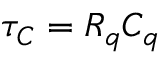<formula> <loc_0><loc_0><loc_500><loc_500>\tau _ { C } = R _ { q } C _ { q }</formula> 